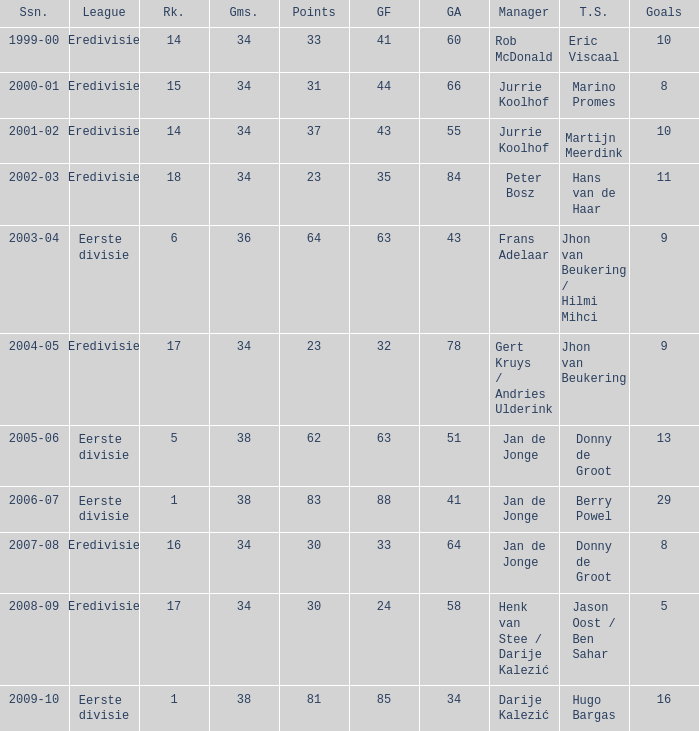How many goals were scored in the 2005-06 season? 13.0. 